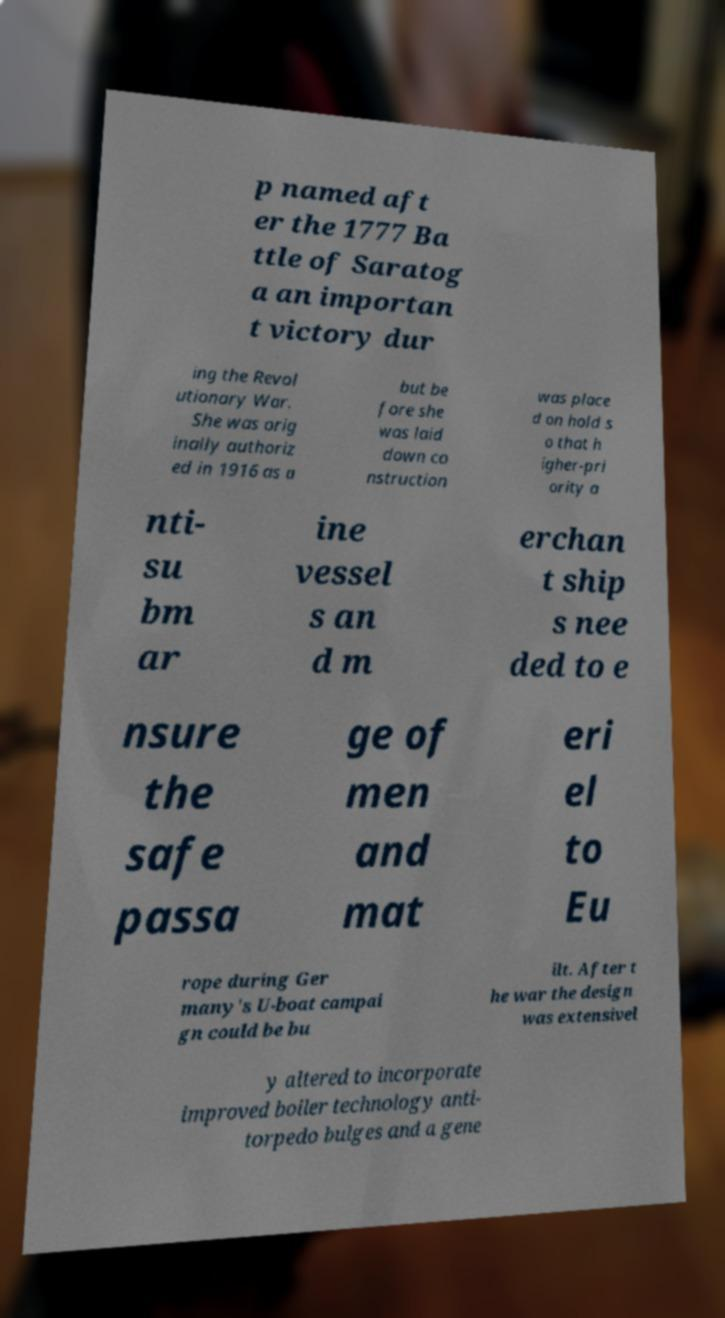Please identify and transcribe the text found in this image. p named aft er the 1777 Ba ttle of Saratog a an importan t victory dur ing the Revol utionary War. She was orig inally authoriz ed in 1916 as a but be fore she was laid down co nstruction was place d on hold s o that h igher-pri ority a nti- su bm ar ine vessel s an d m erchan t ship s nee ded to e nsure the safe passa ge of men and mat eri el to Eu rope during Ger many's U-boat campai gn could be bu ilt. After t he war the design was extensivel y altered to incorporate improved boiler technology anti- torpedo bulges and a gene 